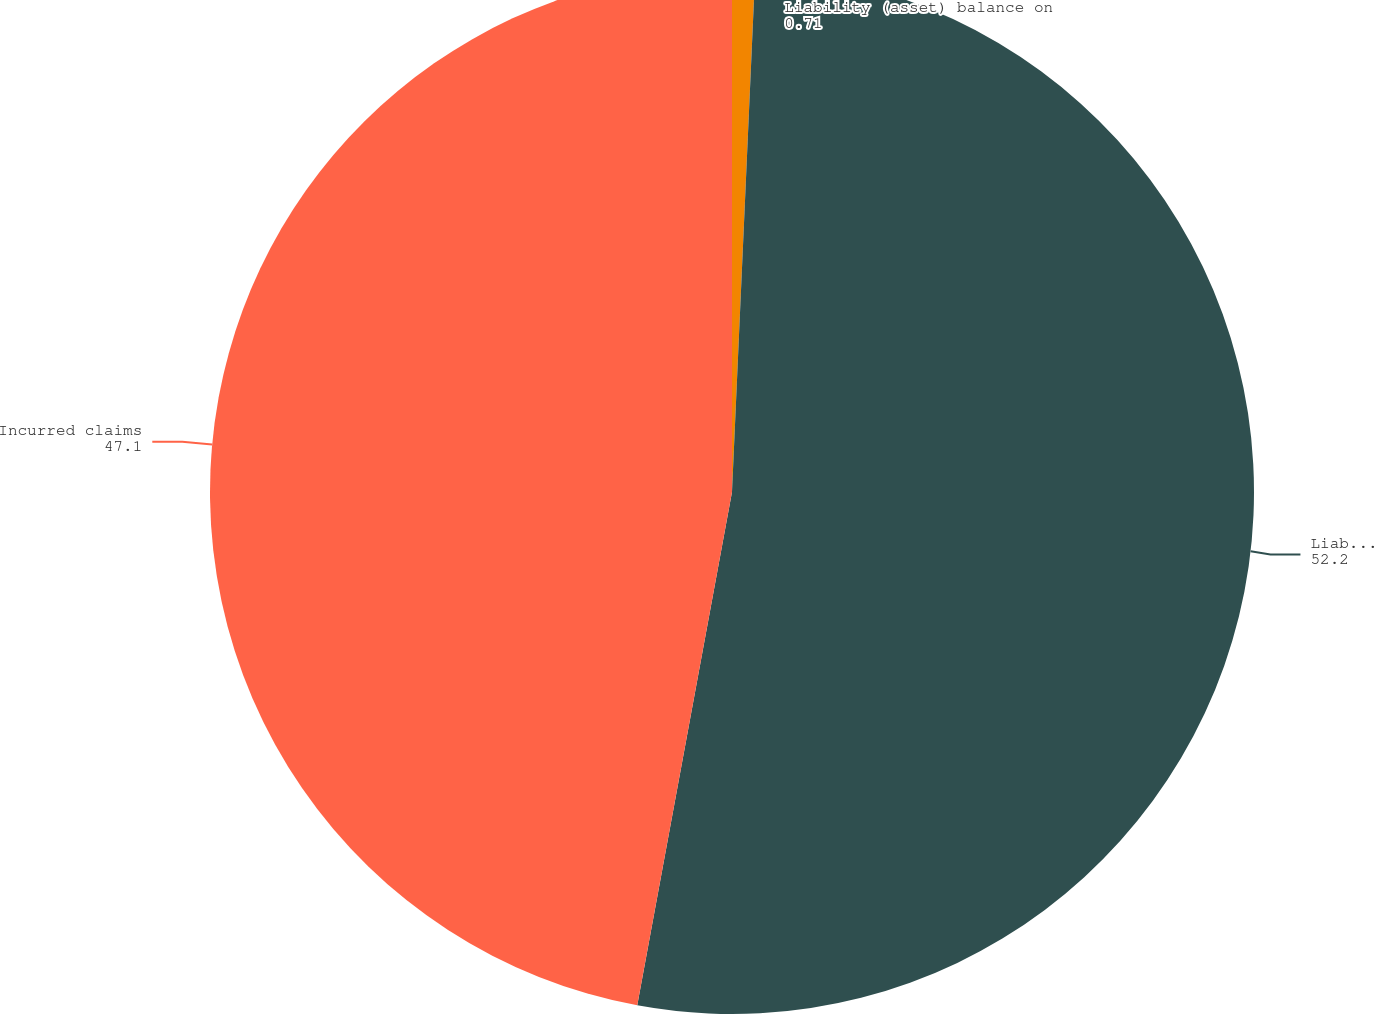<chart> <loc_0><loc_0><loc_500><loc_500><pie_chart><fcel>Liability (asset) balance on<fcel>Liability balance at December<fcel>Incurred claims<nl><fcel>0.71%<fcel>52.2%<fcel>47.1%<nl></chart> 